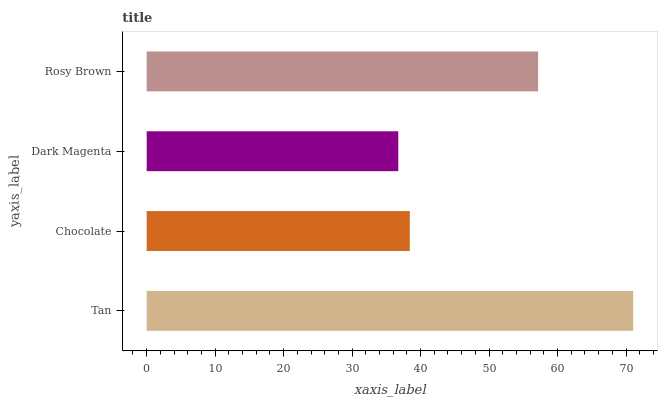Is Dark Magenta the minimum?
Answer yes or no. Yes. Is Tan the maximum?
Answer yes or no. Yes. Is Chocolate the minimum?
Answer yes or no. No. Is Chocolate the maximum?
Answer yes or no. No. Is Tan greater than Chocolate?
Answer yes or no. Yes. Is Chocolate less than Tan?
Answer yes or no. Yes. Is Chocolate greater than Tan?
Answer yes or no. No. Is Tan less than Chocolate?
Answer yes or no. No. Is Rosy Brown the high median?
Answer yes or no. Yes. Is Chocolate the low median?
Answer yes or no. Yes. Is Dark Magenta the high median?
Answer yes or no. No. Is Rosy Brown the low median?
Answer yes or no. No. 